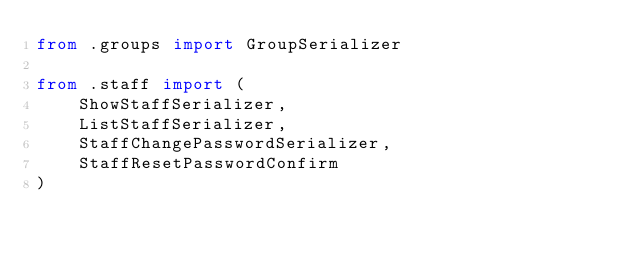<code> <loc_0><loc_0><loc_500><loc_500><_Python_>from .groups import GroupSerializer

from .staff import (
    ShowStaffSerializer,
    ListStaffSerializer,
    StaffChangePasswordSerializer,
    StaffResetPasswordConfirm
)
</code> 